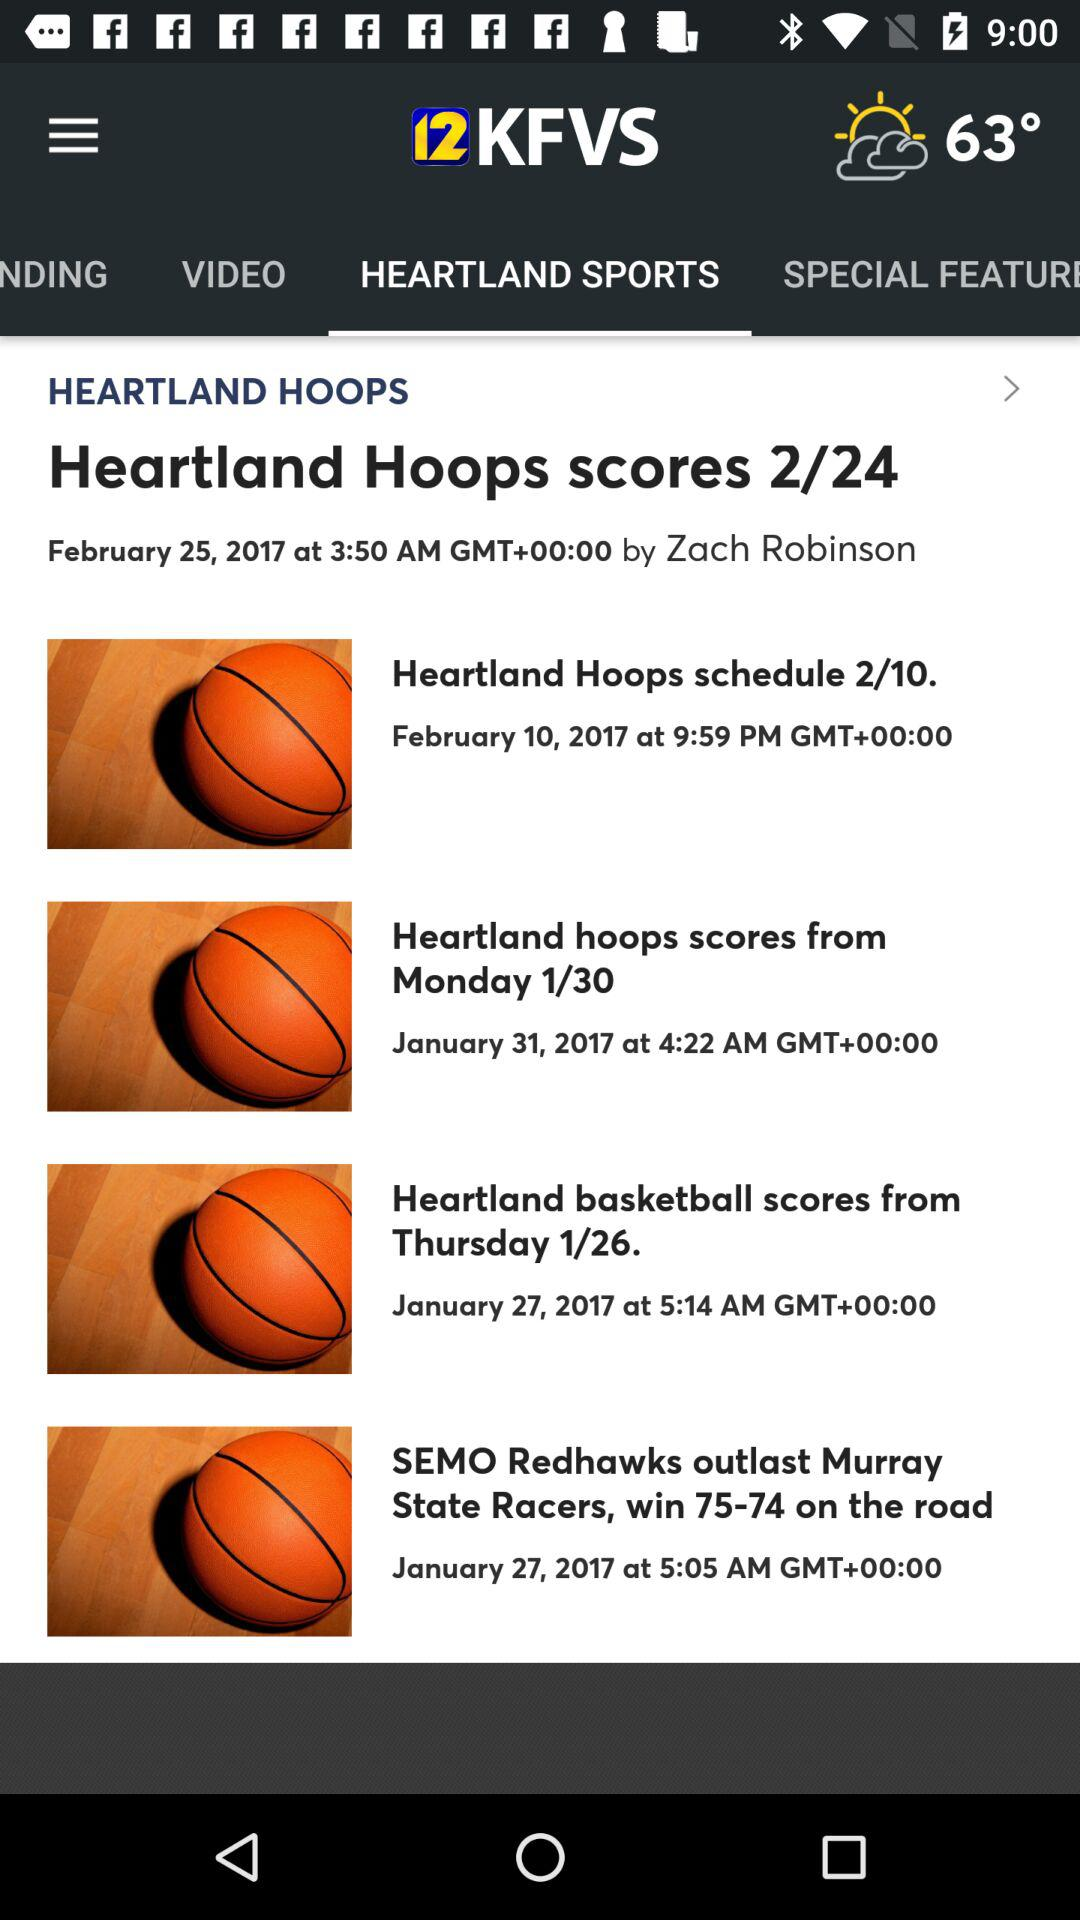Which tab is selected? The selected tab is "HEARTLAND SPORTS". 